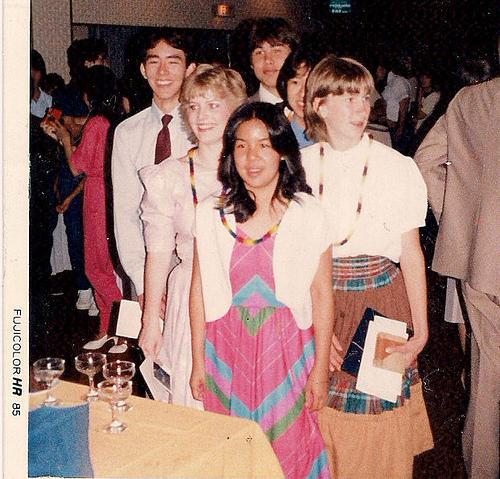What are the people doing?
Keep it brief. Celebrating. What is on the table?
Be succinct. Glasses. Are the people in the picture standing or sitting?
Write a very short answer. Standing. Is the person in front of the line a woman?
Short answer required. Yes. 